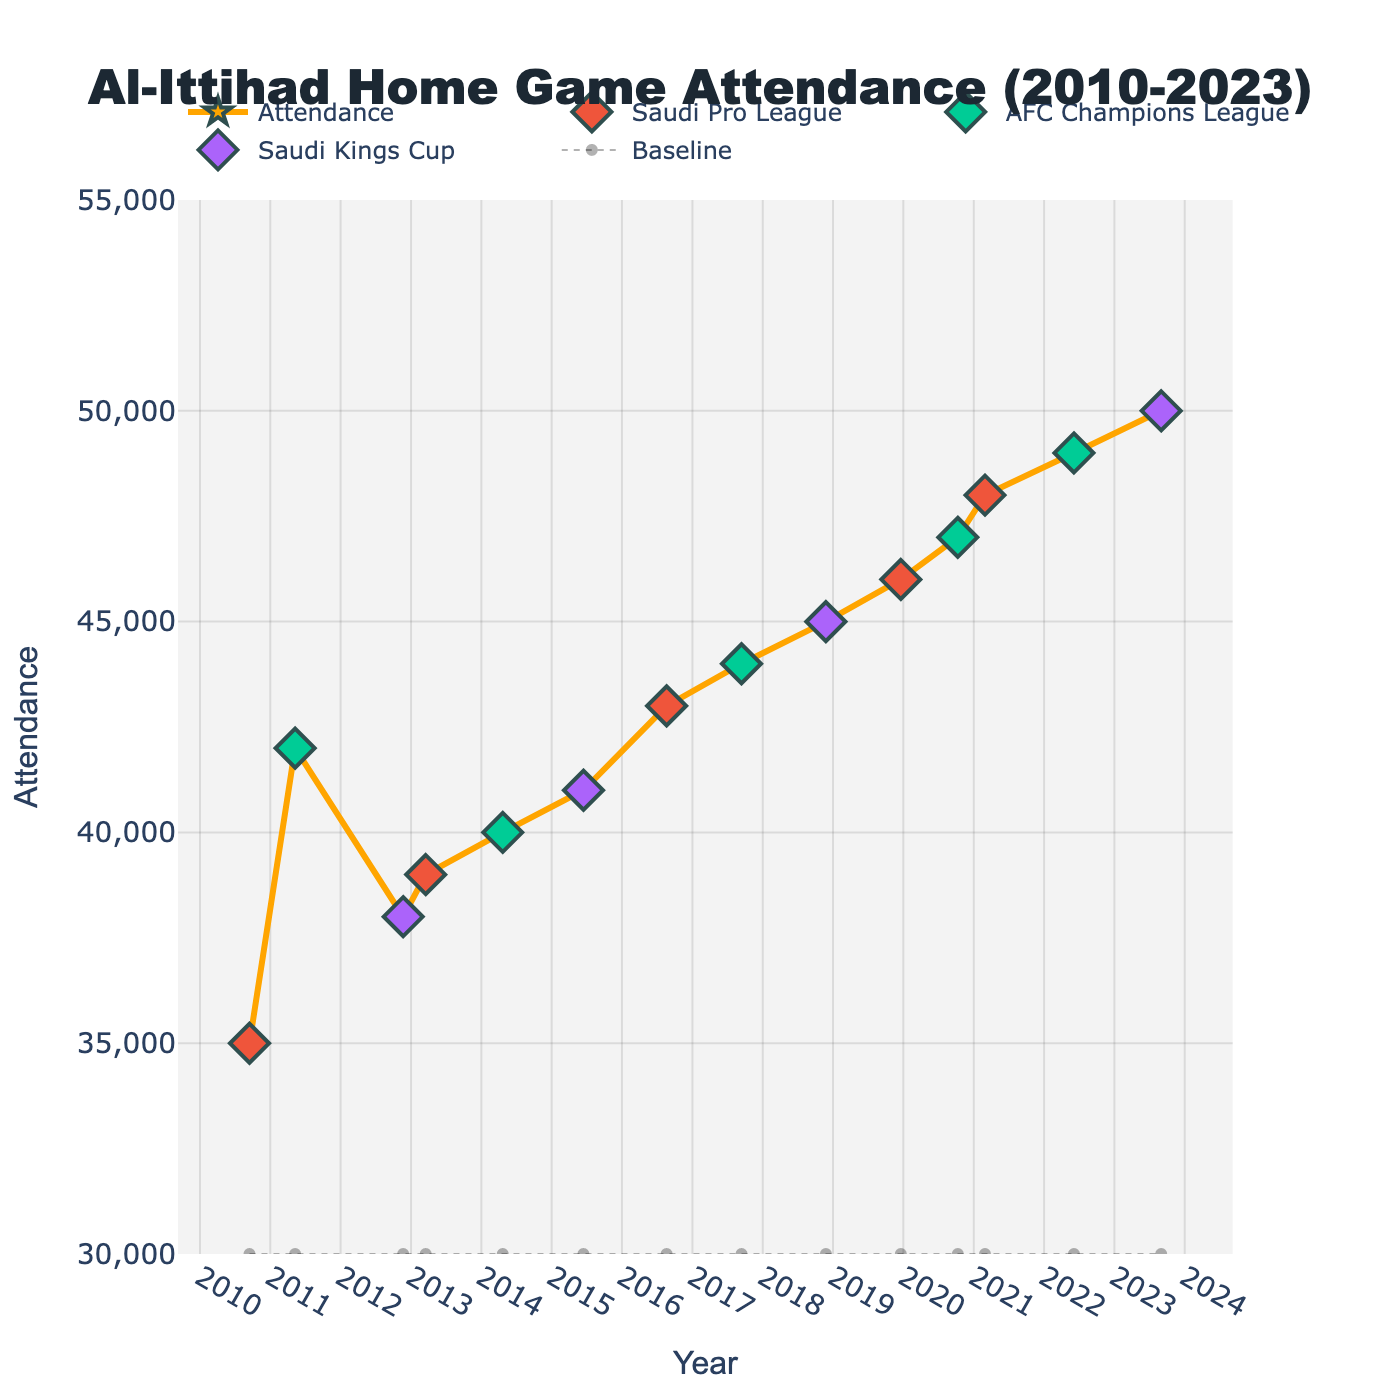What is the title of the plot? The title of the plot is displayed at the top and provides a descriptive overview of the figure. It reads "Al-Ittihad Home Game Attendance (2010-2023)"
Answer: Al-Ittihad Home Game Attendance (2010-2023) What is the maximum attendance recorded, and in which year did it occur? By looking at the peak of the line, the highest attendance is marked around 2023. The y-axis shows the value corresponding to the peak, which is 50,000.
Answer: 2023 Which major tournament appears to correlate with the highest attendance rates? By examining the diamond markers representing major tournaments, the Saudi Kings Cup in 2023 aligns with the peak attendance rate of 50,000.
Answer: Saudi Kings Cup How has attendance trended from 2010 to 2023? Observing the general direction of the line from left to right, attendance has generally increased from the starting point in 2010 to the peak in 2023.
Answer: Increased What is the lowest recorded attendance and during which event did it happen? The lowest point on the plot is around 2010 with an attendance of around 35,000 during the Saudi Pro League.
Answer: 2010, Saudi Pro League Compare the attendance rates of AFC Champions League matches over the years. Identify the diamond markers for AFC Champions League games and observe their corresponding y-values. The attendance rates for AFC Champions League matches steadily increased: approximately 42,000 (2011), 40,000 (2014), 44,000 (2017), 47,000 (2020), and 49,000 (2022).
Answer: Increased Which year had the second-highest attendance at Al-Ittihad home games? By locating the second-highest peak on the plot, the year is around 2022 with an attendance of 49,000.
Answer: 2022 What is the average attendance rate for Saudi Pro League matches based on the data provided? Identify the attendance rates for Saudi Pro League matches: 35,000 (2010), 39,000 (2013), 43,000 (2016), 46,000 (2019), 48,000 (2021). Summing these gives 211,000, and the average is 211,000 / 5 = 42,200.
Answer: 42,200 Between which years does the plot show the most significant increase in attendance? By noting steep rises, the most prominent increase is from 2018 to 2019, where the attendance jumps from 45,000 to 46,000 or from 2022 to 2023 jumping from 49,000 to 50,000.
Answer: 2018-2019 or 2022-2023 